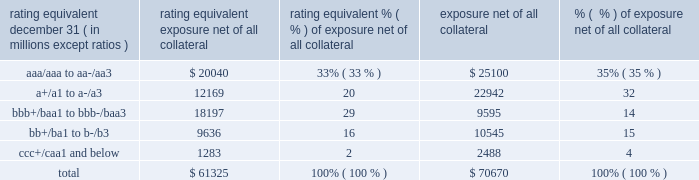Management 2019s discussion and analysis 158 jpmorgan chase & co./2012 annual report the table summarizes the ratings profile by derivative counterparty of the firm 2019s derivative receivables , including credit derivatives , net of other liquid securities collateral , for the dates indicated .
Ratings profile of derivative receivables .
As noted above , the firm uses collateral agreements to mitigate counterparty credit risk .
The percentage of the firm 2019s derivatives transactions subject to collateral agreements 2013 excluding foreign exchange spot trades , which are not typically covered by collateral agreements due to their short maturity 2013 was 88% ( 88 % ) as of december 31 , 2012 , unchanged compared with december 31 , 2011 .
Credit derivatives credit derivatives are financial instruments whose value is derived from the credit risk associated with the debt of a third party issuer ( the reference entity ) and which allow one party ( the protection purchaser ) to transfer that risk to another party ( the protection seller ) when the reference entity suffers a credit event .
If no credit event has occurred , the protection seller makes no payments to the protection purchaser .
For a more detailed description of credit derivatives , see credit derivatives in note 6 on pages 218 2013227 of this annual report .
The firm uses credit derivatives for two primary purposes : first , in its capacity as a market-maker ; and second , as an end-user , to manage the firm 2019s own credit risk associated with various exposures .
Included in end-user activities are credit derivatives used to mitigate the credit risk associated with traditional lending activities ( loans and unfunded commitments ) and derivatives counterparty exposure in the firm 2019s wholesale businesses ( 201ccredit portfolio management 201d activities ) .
Information on credit portfolio management activities is provided in the table below .
In addition , the firm uses credit derivatives as an end-user to manage other exposures , including credit risk arising from certain afs securities and from certain securities held in the firm 2019s market making businesses .
These credit derivatives , as well as the synthetic credit portfolio , are not included in credit portfolio management activities ; for further information on these credit derivatives as well as credit derivatives used in the firm 2019s capacity as a market maker in credit derivatives , see credit derivatives in note 6 on pages 226 2013227 of this annual report. .
What percentage of derivative receivables was junk rated in 2012? 
Computations: (15 + 4)
Answer: 19.0. 